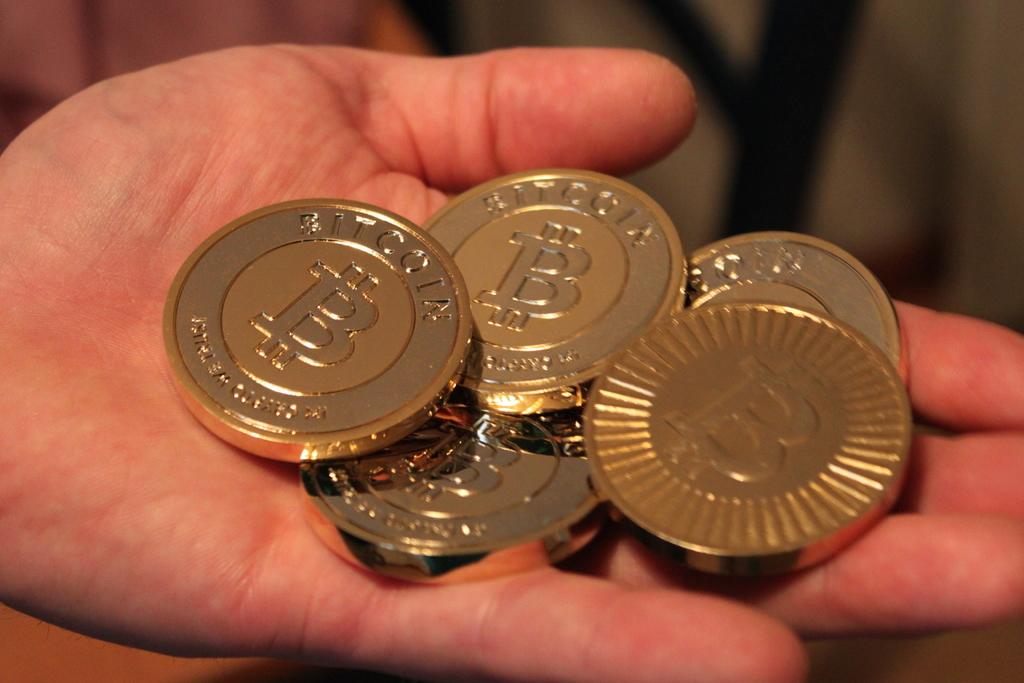<image>
Describe the image concisely. Someone is holding and showing five bitcoins in his palm. 